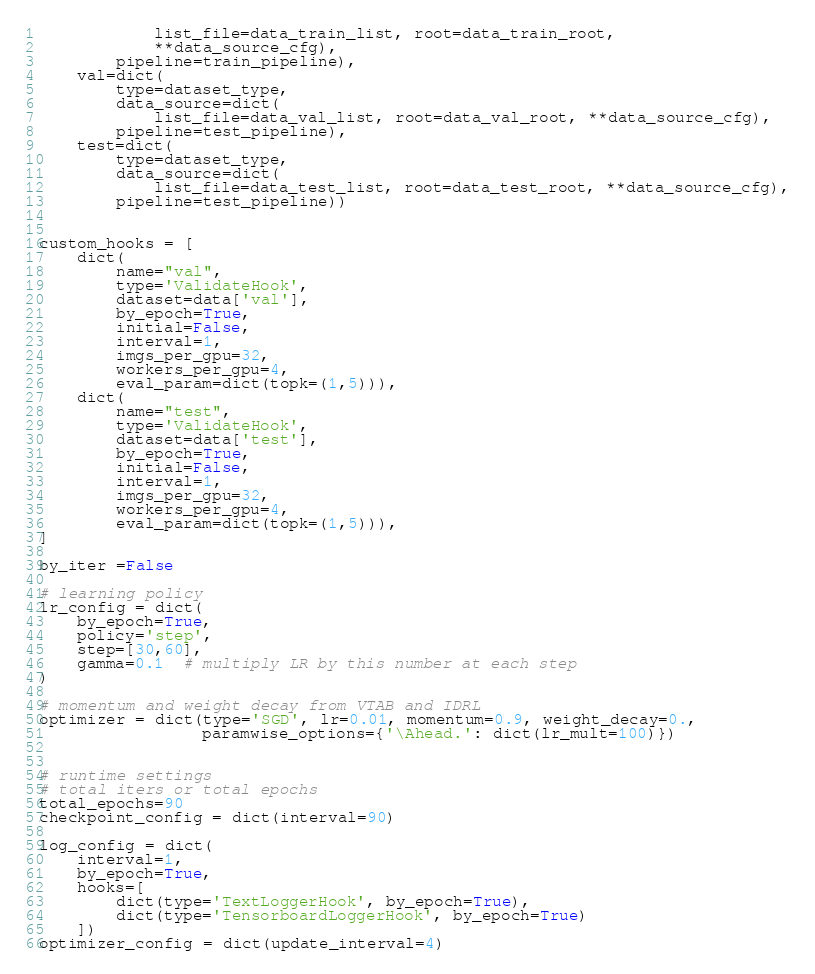<code> <loc_0><loc_0><loc_500><loc_500><_Python_>            list_file=data_train_list, root=data_train_root,
            **data_source_cfg),
        pipeline=train_pipeline),
    val=dict(
        type=dataset_type,
        data_source=dict(
            list_file=data_val_list, root=data_val_root, **data_source_cfg),
        pipeline=test_pipeline),
    test=dict(
        type=dataset_type,
        data_source=dict(
            list_file=data_test_list, root=data_test_root, **data_source_cfg),
        pipeline=test_pipeline))


custom_hooks = [
    dict(
        name="val",
        type='ValidateHook',
        dataset=data['val'],
        by_epoch=True,
        initial=False,
        interval=1,
        imgs_per_gpu=32,
        workers_per_gpu=4,
        eval_param=dict(topk=(1,5))),
    dict(
        name="test",
        type='ValidateHook',
        dataset=data['test'],
        by_epoch=True,
        initial=False,
        interval=1,
        imgs_per_gpu=32,
        workers_per_gpu=4,
        eval_param=dict(topk=(1,5))),
]

by_iter =False

# learning policy
lr_config = dict(
    by_epoch=True,
    policy='step',
    step=[30,60],
    gamma=0.1  # multiply LR by this number at each step
)

# momentum and weight decay from VTAB and IDRL
optimizer = dict(type='SGD', lr=0.01, momentum=0.9, weight_decay=0.,
                 paramwise_options={'\Ahead.': dict(lr_mult=100)})


# runtime settings
# total iters or total epochs
total_epochs=90
checkpoint_config = dict(interval=90)

log_config = dict(
    interval=1,
    by_epoch=True,
    hooks=[
        dict(type='TextLoggerHook', by_epoch=True),
        dict(type='TensorboardLoggerHook', by_epoch=True)
    ])
optimizer_config = dict(update_interval=4)
</code> 